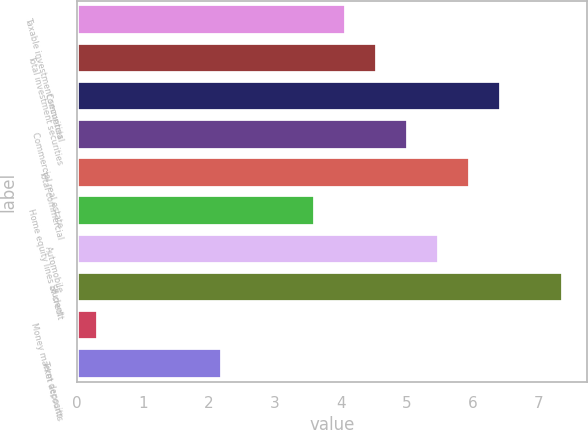Convert chart to OTSL. <chart><loc_0><loc_0><loc_500><loc_500><bar_chart><fcel>Taxable investment securities<fcel>Total investment securities<fcel>Commercial<fcel>Commercial real estate<fcel>Total commercial<fcel>Home equity lines of credit<fcel>Automobile<fcel>Student<fcel>Money market accounts<fcel>Term deposits<nl><fcel>4.08<fcel>4.55<fcel>6.43<fcel>5.02<fcel>5.96<fcel>3.61<fcel>5.49<fcel>7.37<fcel>0.32<fcel>2.2<nl></chart> 